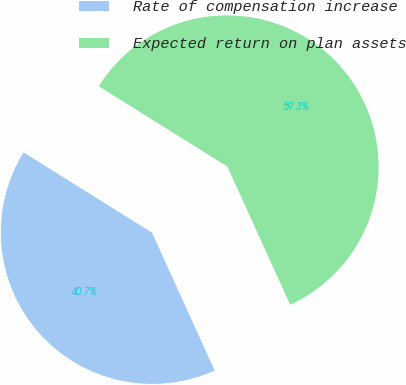Convert chart. <chart><loc_0><loc_0><loc_500><loc_500><pie_chart><fcel>Rate of compensation increase<fcel>Expected return on plan assets<nl><fcel>40.68%<fcel>59.32%<nl></chart> 